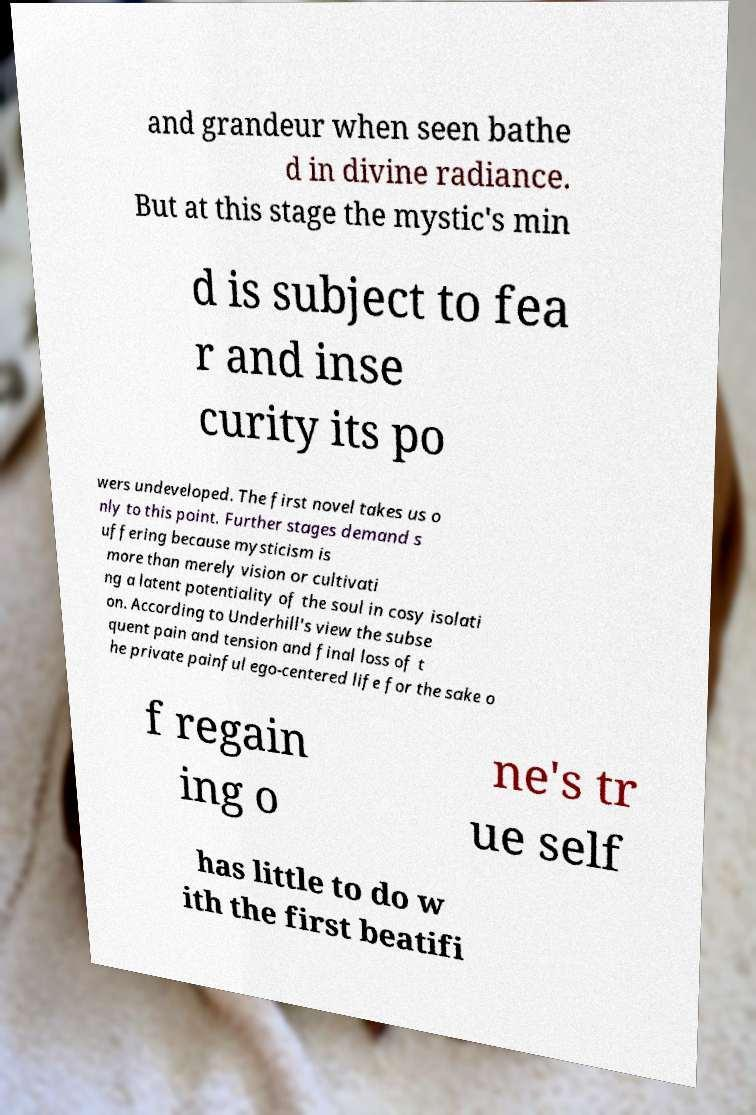Can you accurately transcribe the text from the provided image for me? and grandeur when seen bathe d in divine radiance. But at this stage the mystic's min d is subject to fea r and inse curity its po wers undeveloped. The first novel takes us o nly to this point. Further stages demand s uffering because mysticism is more than merely vision or cultivati ng a latent potentiality of the soul in cosy isolati on. According to Underhill's view the subse quent pain and tension and final loss of t he private painful ego-centered life for the sake o f regain ing o ne's tr ue self has little to do w ith the first beatifi 